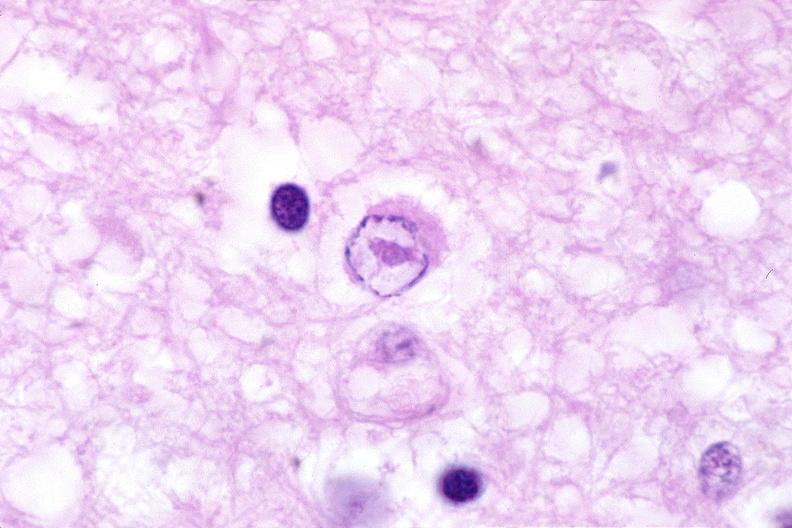s fetus developing very early present?
Answer the question using a single word or phrase. No 